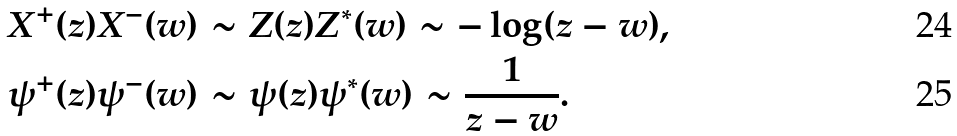<formula> <loc_0><loc_0><loc_500><loc_500>X ^ { + } ( z ) X ^ { - } ( w ) & \sim Z ( z ) Z ^ { * } ( w ) \sim - \log ( z - w ) , \\ \psi ^ { + } ( z ) \psi ^ { - } ( w ) & \sim \psi ( z ) \psi ^ { * } ( w ) \sim \frac { 1 } { z - w } .</formula> 